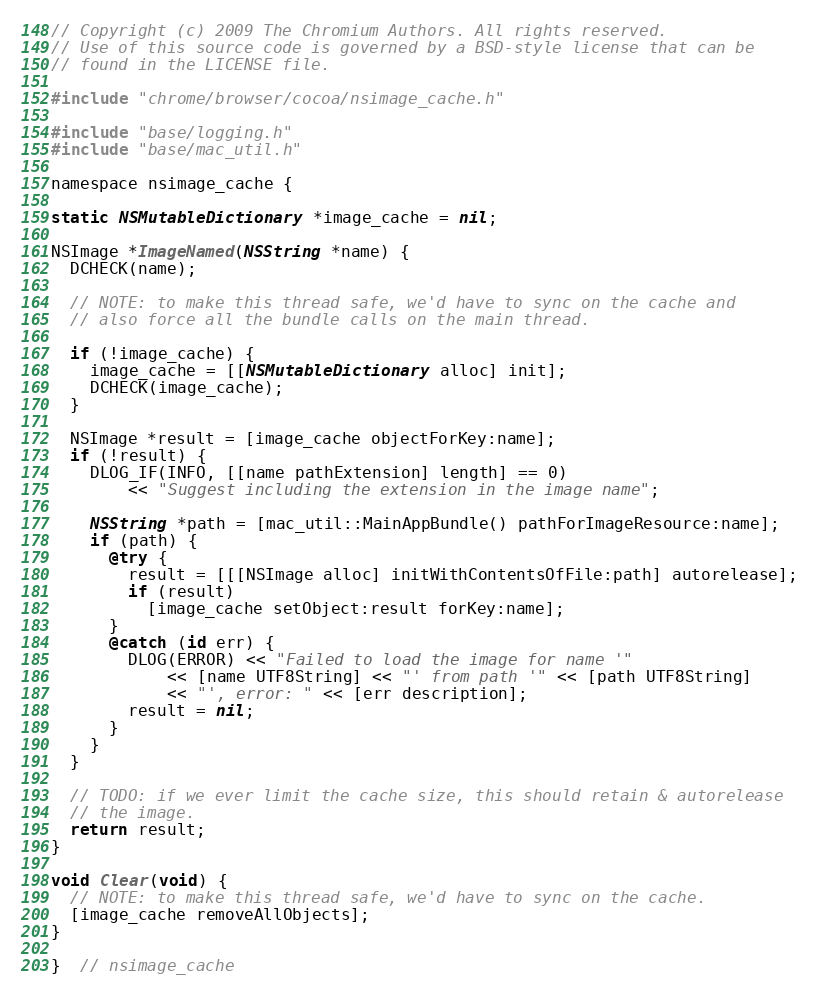<code> <loc_0><loc_0><loc_500><loc_500><_ObjectiveC_>// Copyright (c) 2009 The Chromium Authors. All rights reserved.
// Use of this source code is governed by a BSD-style license that can be
// found in the LICENSE file.

#include "chrome/browser/cocoa/nsimage_cache.h"

#include "base/logging.h"
#include "base/mac_util.h"

namespace nsimage_cache {

static NSMutableDictionary *image_cache = nil;

NSImage *ImageNamed(NSString *name) {
  DCHECK(name);

  // NOTE: to make this thread safe, we'd have to sync on the cache and
  // also force all the bundle calls on the main thread.

  if (!image_cache) {
    image_cache = [[NSMutableDictionary alloc] init];
    DCHECK(image_cache);
  }

  NSImage *result = [image_cache objectForKey:name];
  if (!result) {
    DLOG_IF(INFO, [[name pathExtension] length] == 0)
        << "Suggest including the extension in the image name";

    NSString *path = [mac_util::MainAppBundle() pathForImageResource:name];
    if (path) {
      @try {
        result = [[[NSImage alloc] initWithContentsOfFile:path] autorelease];
        if (result)
          [image_cache setObject:result forKey:name];
      }
      @catch (id err) {
        DLOG(ERROR) << "Failed to load the image for name '"
            << [name UTF8String] << "' from path '" << [path UTF8String]
            << "', error: " << [err description];
        result = nil;
      }
    }
  }

  // TODO: if we ever limit the cache size, this should retain & autorelease
  // the image.
  return result;
}

void Clear(void) {
  // NOTE: to make this thread safe, we'd have to sync on the cache.
  [image_cache removeAllObjects];
}

}  // nsimage_cache
</code> 